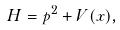<formula> <loc_0><loc_0><loc_500><loc_500>H = p ^ { 2 } + V ( x ) ,</formula> 